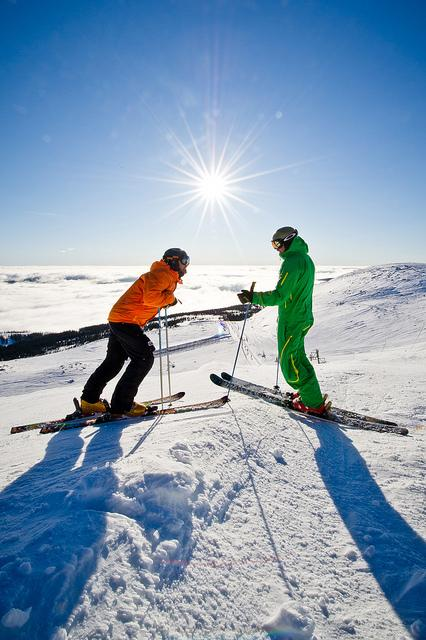What part of the world are the skiers most likely in? europe 